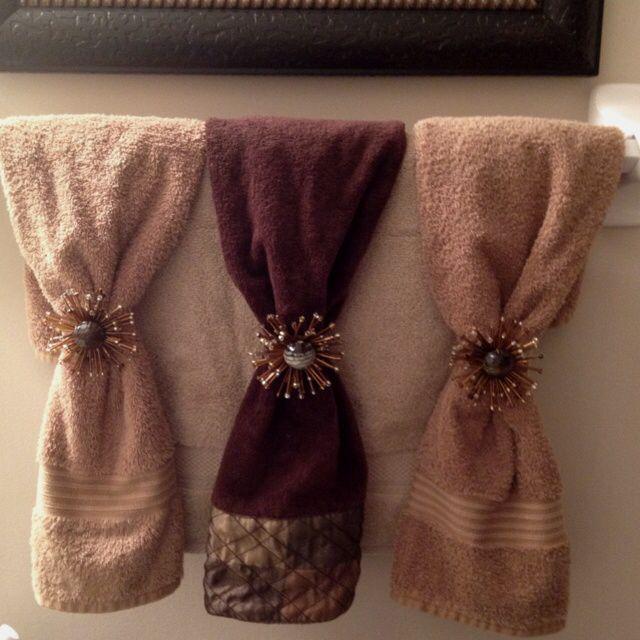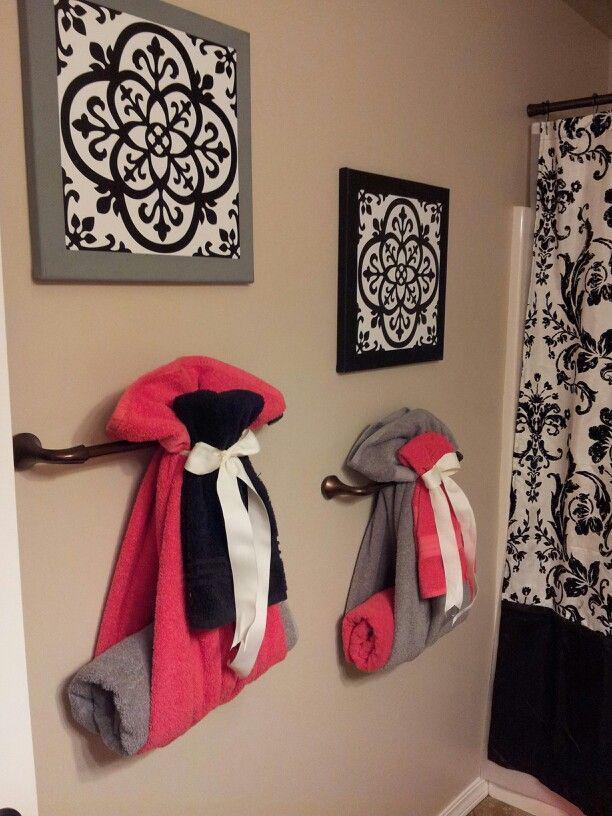The first image is the image on the left, the second image is the image on the right. Given the left and right images, does the statement "Each image shows multiple hand towel decor ideas." hold true? Answer yes or no. No. 